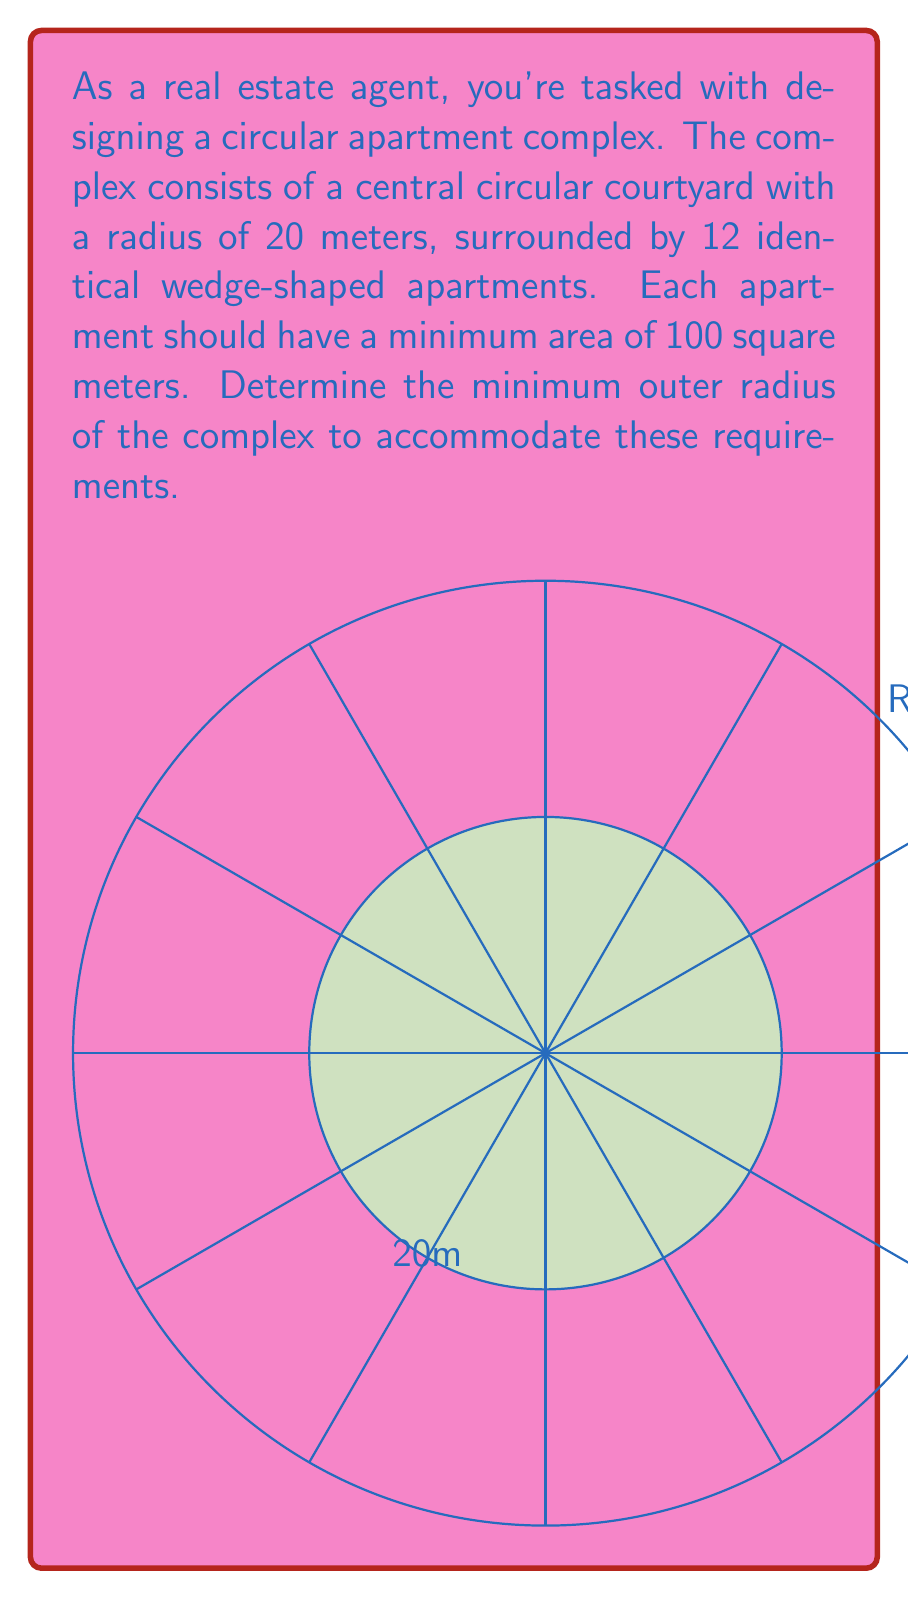Show me your answer to this math problem. Let's approach this step-by-step:

1) First, we need to calculate the area of each wedge-shaped apartment. The total area of the complex minus the area of the central courtyard, divided by 12, should be at least 100 square meters.

2) Let $R$ be the outer radius of the complex. The area of the entire complex is $\pi R^2$, and the area of the central courtyard is $\pi (20)^2 = 400\pi$ square meters.

3) The area of each apartment can be expressed as:

   $$A_{apartment} = \frac{\pi R^2 - 400\pi}{12} \geq 100$$

4) Solving this inequality:

   $$\pi R^2 - 400\pi \geq 1200$$
   $$\pi R^2 \geq 1200 + 400\pi$$
   $$R^2 \geq \frac{1200 + 400\pi}{\pi}$$
   $$R \geq \sqrt{\frac{1200 + 400\pi}{\pi}}$$

5) Calculating this value:

   $$R \geq \sqrt{\frac{1200 + 400\pi}{\pi}} \approx 39.89 \text{ meters}$$

6) Since we need the minimum outer radius, we round up to the nearest whole number to ensure we meet the minimum area requirement.
Answer: 40 meters 